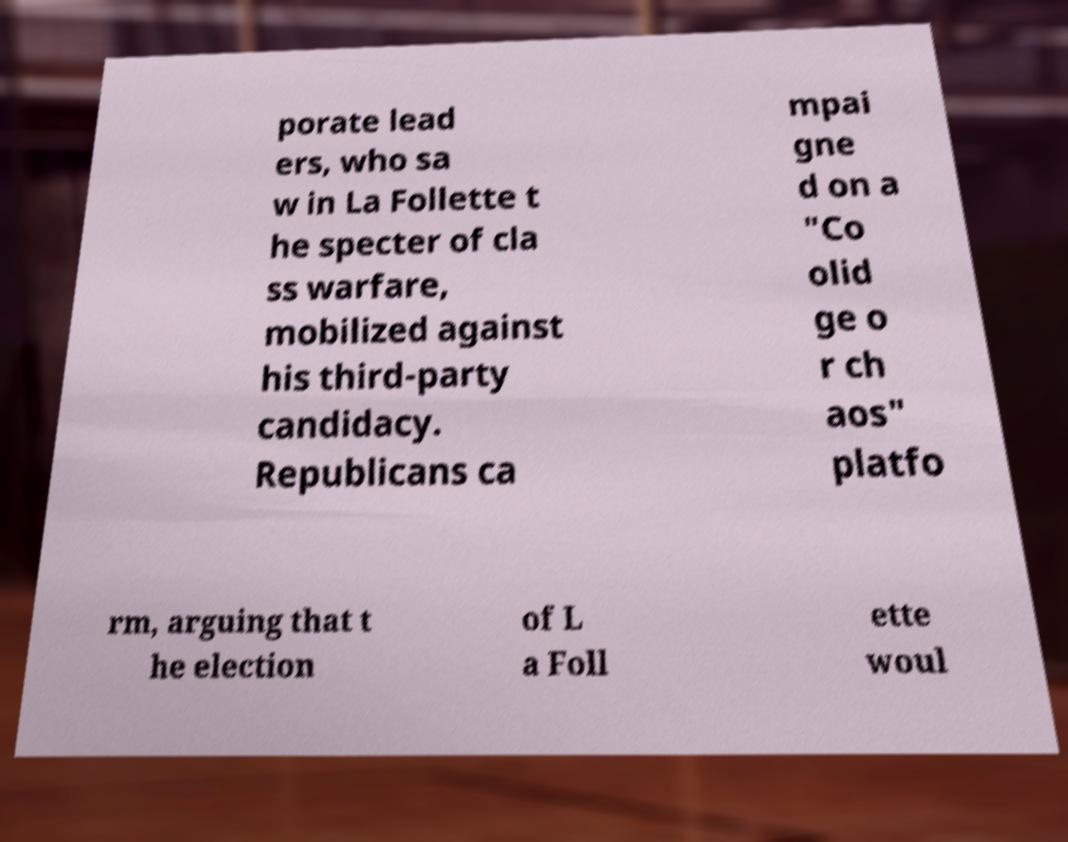There's text embedded in this image that I need extracted. Can you transcribe it verbatim? porate lead ers, who sa w in La Follette t he specter of cla ss warfare, mobilized against his third-party candidacy. Republicans ca mpai gne d on a "Co olid ge o r ch aos" platfo rm, arguing that t he election of L a Foll ette woul 